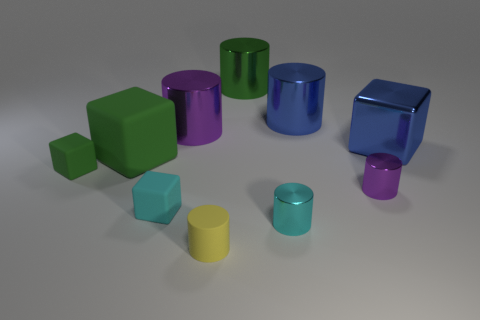How many objects are either yellow rubber things or metallic things that are left of the yellow rubber cylinder?
Keep it short and to the point. 2. Do the yellow cylinder and the green object to the right of the yellow cylinder have the same size?
Your response must be concise. No. How many cylinders are either small green matte objects or green matte things?
Offer a terse response. 0. How many things are both behind the metallic cube and left of the tiny yellow rubber object?
Provide a succinct answer. 1. How many other objects are there of the same color as the large metal cube?
Provide a succinct answer. 1. There is a purple shiny thing that is behind the tiny green matte object; what is its shape?
Ensure brevity in your answer.  Cylinder. Is the blue cube made of the same material as the big purple thing?
Keep it short and to the point. Yes. Is there any other thing that is the same size as the cyan cylinder?
Ensure brevity in your answer.  Yes. What number of large blue objects are to the left of the big blue metal block?
Your answer should be compact. 1. The object that is behind the big blue thing that is on the left side of the large blue block is what shape?
Provide a succinct answer. Cylinder. 